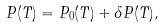<formula> <loc_0><loc_0><loc_500><loc_500>P ( T ) = P _ { 0 } ( T ) + \delta P ( T ) ,</formula> 